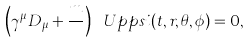Convert formula to latex. <formula><loc_0><loc_0><loc_500><loc_500>\left ( \gamma ^ { \mu } D _ { \mu } + \frac { m } { } \right ) \ U p p s i ( t , r , \theta , \phi ) = 0 ,</formula> 